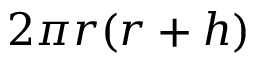Convert formula to latex. <formula><loc_0><loc_0><loc_500><loc_500>2 \pi r ( r + h ) \,</formula> 